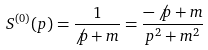Convert formula to latex. <formula><loc_0><loc_0><loc_500><loc_500>S ^ { ( 0 ) } ( p ) = \frac { 1 } { \not p + m } = \frac { - \not p + m } { p ^ { 2 } + m ^ { 2 } }</formula> 